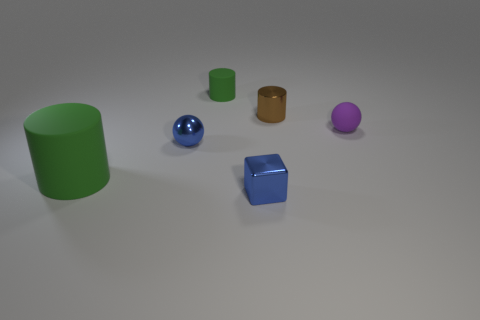Subtract all tiny cylinders. How many cylinders are left? 1 Subtract 1 cylinders. How many cylinders are left? 2 Add 1 metal things. How many objects exist? 7 Subtract all spheres. How many objects are left? 4 Add 3 small purple shiny blocks. How many small purple shiny blocks exist? 3 Subtract 1 purple balls. How many objects are left? 5 Subtract all tiny purple matte things. Subtract all tiny blue blocks. How many objects are left? 4 Add 4 green cylinders. How many green cylinders are left? 6 